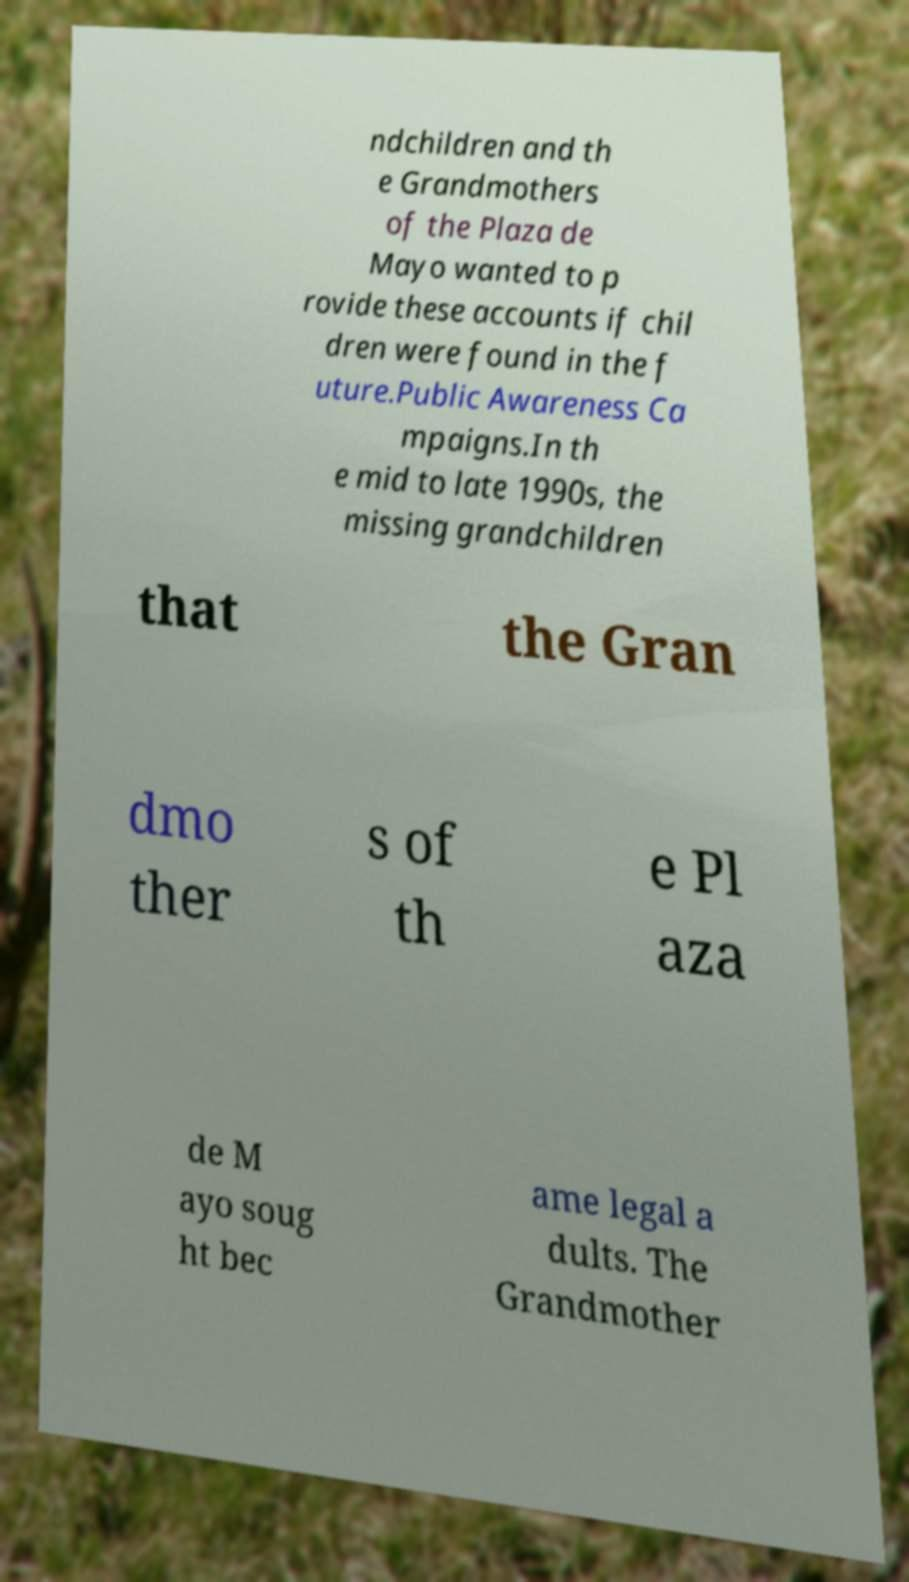Could you extract and type out the text from this image? ndchildren and th e Grandmothers of the Plaza de Mayo wanted to p rovide these accounts if chil dren were found in the f uture.Public Awareness Ca mpaigns.In th e mid to late 1990s, the missing grandchildren that the Gran dmo ther s of th e Pl aza de M ayo soug ht bec ame legal a dults. The Grandmother 